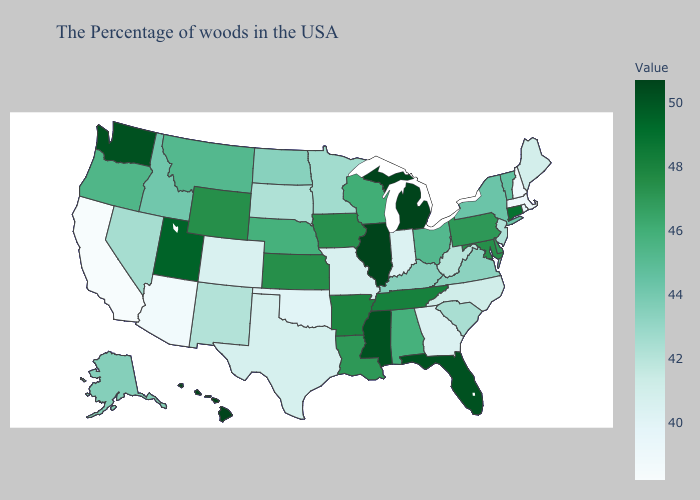Which states have the lowest value in the USA?
Concise answer only. California. Does Michigan have the lowest value in the USA?
Quick response, please. No. Among the states that border Kentucky , does Illinois have the lowest value?
Be succinct. No. Does California have the lowest value in the USA?
Short answer required. Yes. Does South Dakota have a higher value than Indiana?
Short answer required. Yes. Which states have the lowest value in the West?
Keep it brief. California. Does Illinois have the highest value in the USA?
Write a very short answer. Yes. Does the map have missing data?
Keep it brief. No. 